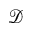Convert formula to latex. <formula><loc_0><loc_0><loc_500><loc_500>\mathcal { D }</formula> 